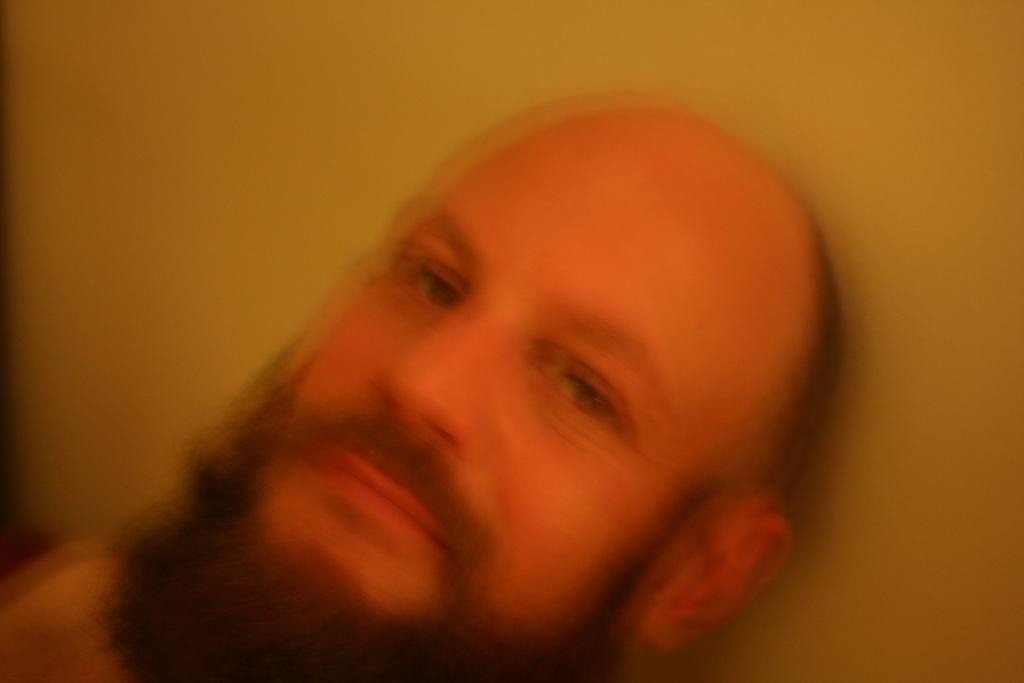What is the main subject of the picture? The main subject of the picture is a blurry image of a person. Can you describe the background of the image? There may be a wall behind the person in the image. What type of crow is perched on the person's neck in the image? There is no crow present in the image; the main subject is a blurry image of a person. 